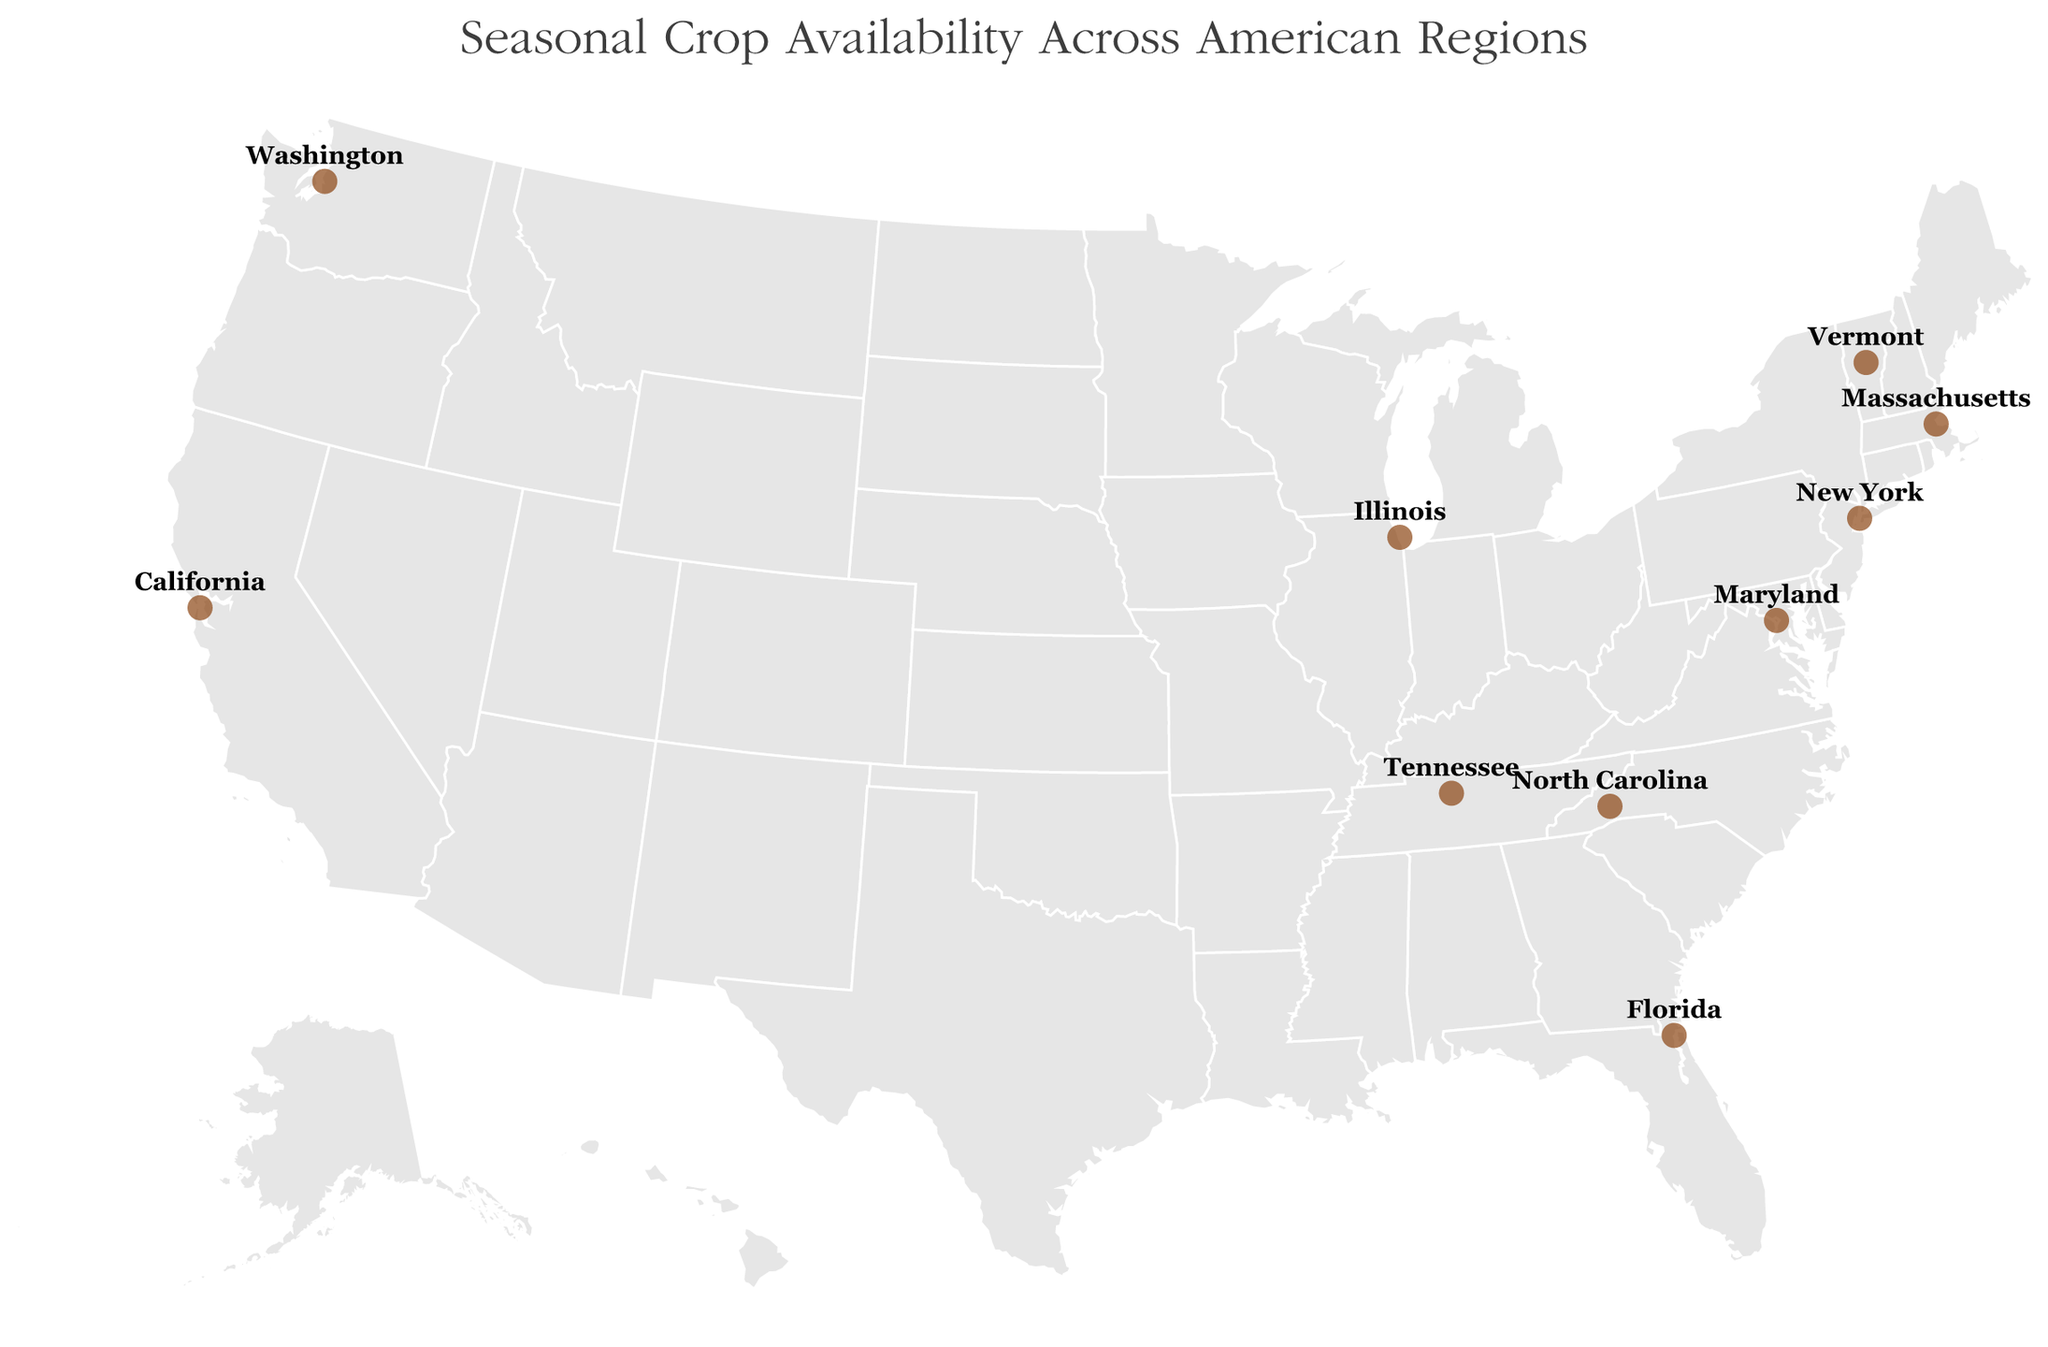What crop is available in Vermont during Summer? The tooltip for Vermont shows the seasonal crops. In Summer, it is Tomatoes.
Answer: Tomatoes Which location offers Peaches in Summer? By reviewing the tooltip descriptions for each location, North Carolina is the location providing Peaches in Summer.
Answer: North Carolina What are the Winter crops in New York? The tooltip for New York displays Brussels Sprouts as the available Winter crop.
Answer: Brussels Sprouts Compare the Summer and Winter crops in Massachusetts. How do they differ? The tooltip description for Massachusetts lists Blueberries in Summer and Parsnips in Winter, illustrating a change from fruits to root vegetables.
Answer: Summer: Blueberries, Winter: Parsnips How many locations provide root vegetables as Winter crops? From the tooltip data: Vermont (Potatoes), Maryland (Turnips), Massachusetts (Parsnips), Tennessee (Carrots), Illinois (Beets), and California (Leeks) all offer root vegetables in Winter, totaling 6 locations.
Answer: 6 Identify the Fall crop in Florida and explain its uniqueness in comparison to other locations' Fall crops. The tooltip for Florida shows Avocados in Fall. Comparing with other locations' fall crops, Avocados stand out since other locations have crops like Apples, Pumpkins, Squash, Cranberries, Pears, Sweet Potatoes, Grapes, Eggplant, and Pomegranates, which are more common in temperate regions unlike Avocados that thrive in warmer climates.
Answer: Avocados Which two states have mushrooms as a seasonal crop and during which season? Reviewing the tooltip data, only Washington lists Morel Mushrooms in Spring; no other state lists mushrooms in any season.
Answer: Washington in Spring What are the Spring and Winter crops in Tennessee, and how are they similar? According to Tennessee's tooltip, Spring Onions are in Spring and Carrots are in Winter. Both are root vegetables.
Answer: Spring: Spring Onions, Winter: Carrots Find the state that offers Citrus Fruits in Winter. The tooltip for Florida indicates Citrus Fruits as the Winter crop.
Answer: Florida Compare the types of crops available in Summer across all locations. Which state offers the most unique type of crop during this season? By examining the Summer crops in all tooltips: Vermont (Tomatoes), North Carolina (Peaches), Maryland (Corn), Massachusetts (Blueberries), Washington (Raspberries), Tennessee (Okra), New York (Zucchini), Florida (Watermelon), Illinois (Green Beans), and California (Figs). California stands out with Figs, which are less common compared to other fruits and vegetables listed.
Answer: California with Figs 